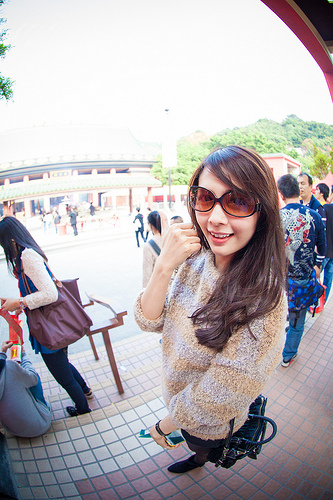<image>
Is there a girl behind the glasses? Yes. From this viewpoint, the girl is positioned behind the glasses, with the glasses partially or fully occluding the girl. 